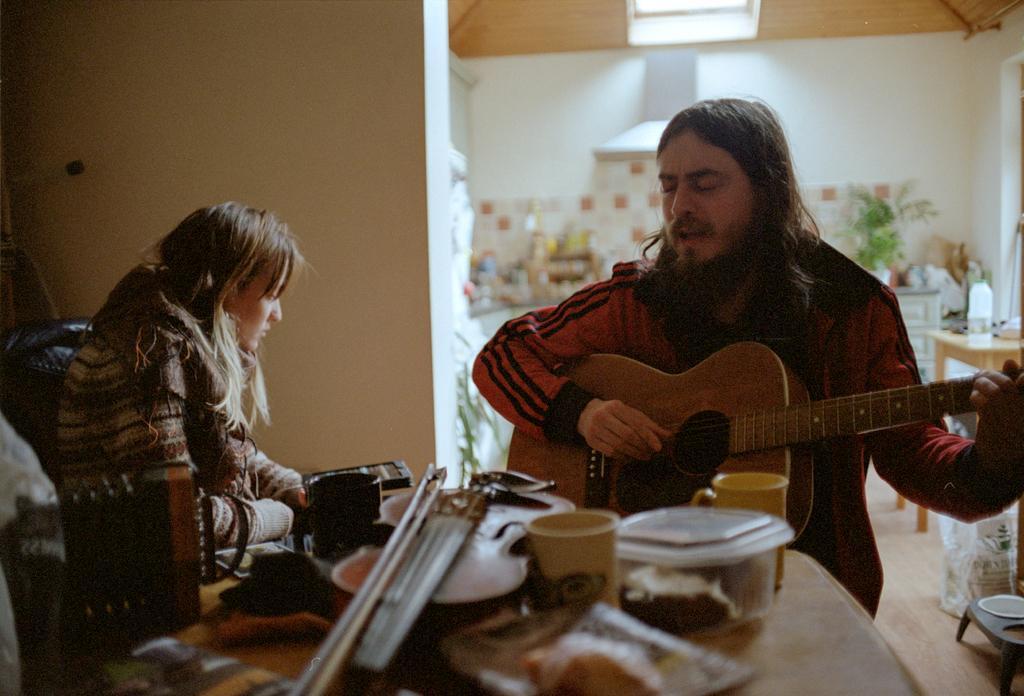Please provide a concise description of this image. Here we can see a woman and a man. He is playing guitar. This is table. On the table there are ups, boxes, and bowls. On the background there is a wall and this is plant. 